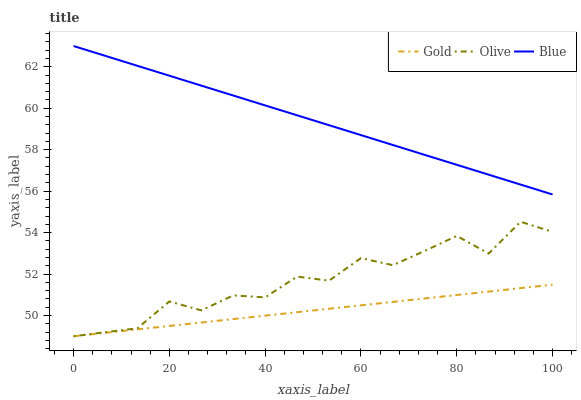Does Blue have the minimum area under the curve?
Answer yes or no. No. Does Gold have the maximum area under the curve?
Answer yes or no. No. Is Blue the smoothest?
Answer yes or no. No. Is Blue the roughest?
Answer yes or no. No. Does Blue have the lowest value?
Answer yes or no. No. Does Gold have the highest value?
Answer yes or no. No. Is Olive less than Blue?
Answer yes or no. Yes. Is Blue greater than Gold?
Answer yes or no. Yes. Does Olive intersect Blue?
Answer yes or no. No. 